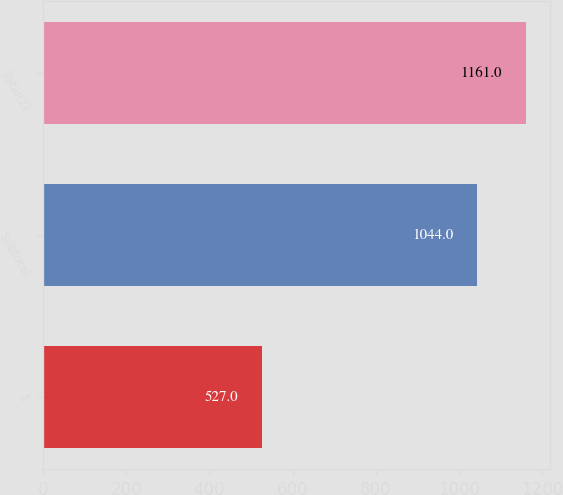<chart> <loc_0><loc_0><loc_500><loc_500><bar_chart><fcel>1<fcel>Subtotal<fcel>Total(2)<nl><fcel>527<fcel>1044<fcel>1161<nl></chart> 